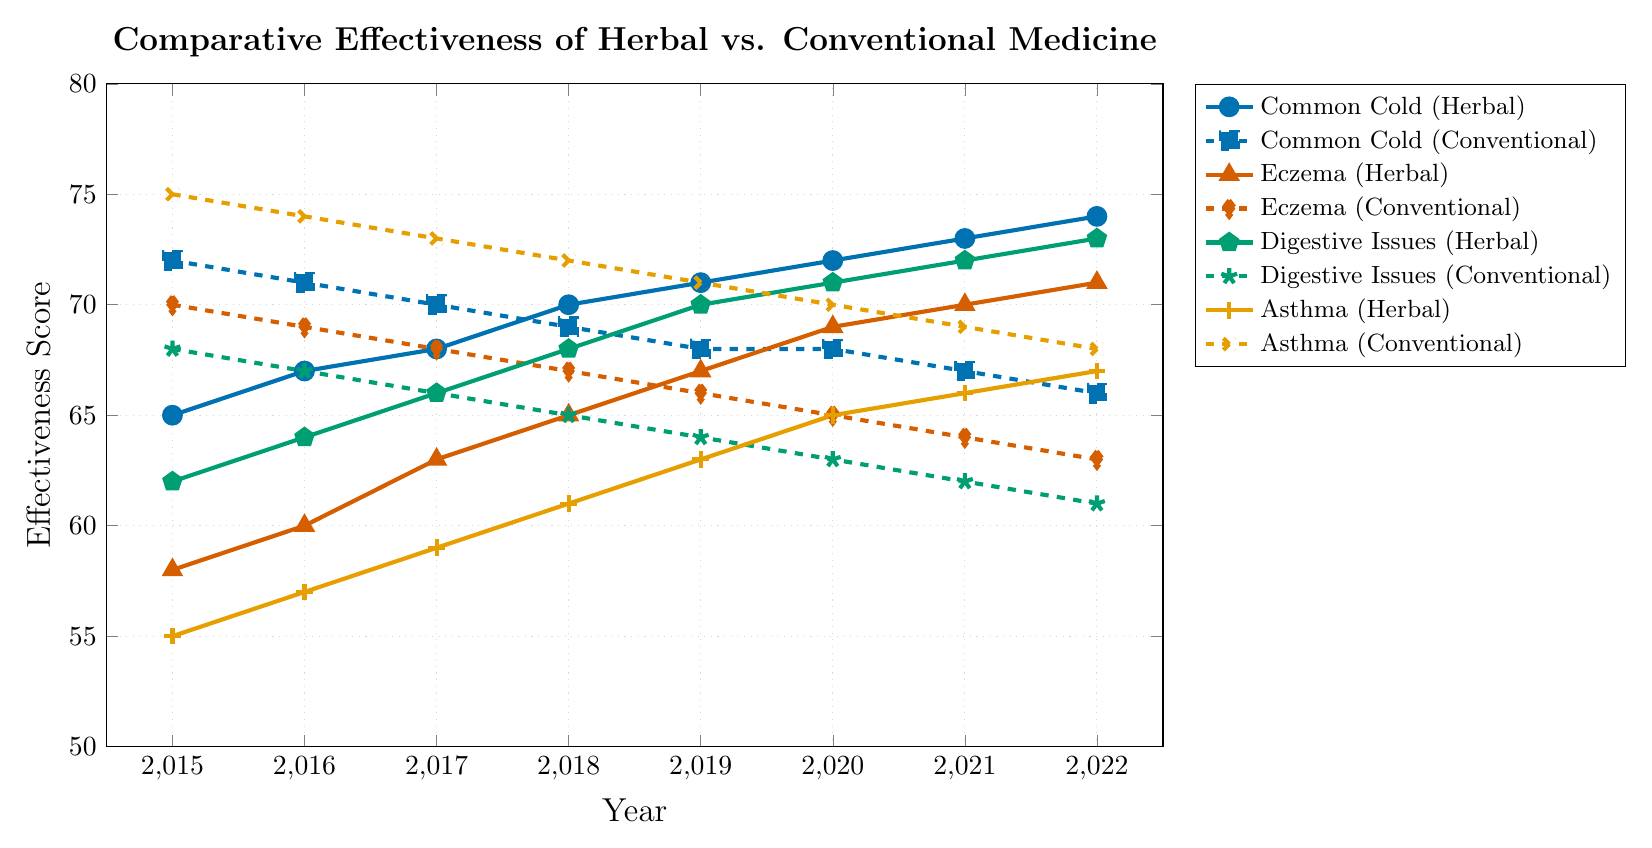What is the trend of effectiveness for Conventional medicine for Asthma from 2015 to 2022? From 2015 to 2022, the effectiveness of Conventional medicine for Asthma decreases. This can be observed by noting that the values drop from 75 in 2015 to 68 in 2022.
Answer: Decreasing Which treatment shows a consistently increasing trend for Digestive Issues from 2015 to 2022? The trend for Digestive Issues (Herbal) shows a consistent increase from 62 in 2015 to 73 in 2022.
Answer: Herbal By how much did the effectiveness of Herbal treatment for Eczema increase between 2015 and 2022? The effectiveness of Herbal treatment for Eczema increased from 58 in 2015 to 71 in 2022. The difference is calculated as 71 - 58 = 13.
Answer: 13 Which year saw the highest effectiveness score for Conventional medicine for Common Cold? The highest effectiveness score for Conventional medicine for Common Cold is in 2015, with a score of 72.
Answer: 2015 Between 2019 and 2022, which treatment for Common Cold has a steeper slope, Herbal or Conventional? Between 2019 and 2022, Herbal treatment for Common Cold increases from 71 to 74, while Conventional treatment decreases from 68 to 66. The slope for Herbal is (74-71)/(2022-2019) = 1, and the slope for Conventional is (66-68)/(2022-2019) = -0.67. Thus, Herbal has a steeper slope.
Answer: Herbal What is the median effectiveness score for Conventional medicine for Digestive Issues from 2015 to 2022? The effectiveness scores for Conventional medicine for Digestive Issues from 2015 to 2022 are [68, 67, 66, 65, 64, 63, 62, 61]. The median is the average of the 4th and 5th values in the ordered list, which is (65 + 64) / 2 = 64.5.
Answer: 64.5 In which year did both Herbal and Conventional treatments for Eczema have the same difference in effectiveness score? The difference in effectiveness scores for Eczema (Herbal - Conventional) is calculated for each year. Only in 2022, both treatments show a difference of 71 - 63 = 8.
Answer: 2022 Which treatment has shown a greater cumulative increase in effectiveness from 2015 to 2022: Herbal for Asthma or Herbal for Digestive Issues? For Herbal Asthma, the increase is (67 - 55) = 12. For Herbal Digestive Issues, the increase is (73 - 62) = 11. The cumulative increase for Herbal Asthma is greater.
Answer: Herbal for Asthma 